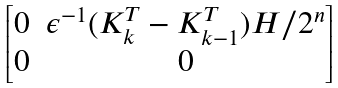Convert formula to latex. <formula><loc_0><loc_0><loc_500><loc_500>\begin{bmatrix} 0 & \epsilon ^ { - 1 } ( K _ { k } ^ { T } - K _ { k - 1 } ^ { T } ) H / 2 ^ { n } \\ 0 & 0 \end{bmatrix}</formula> 